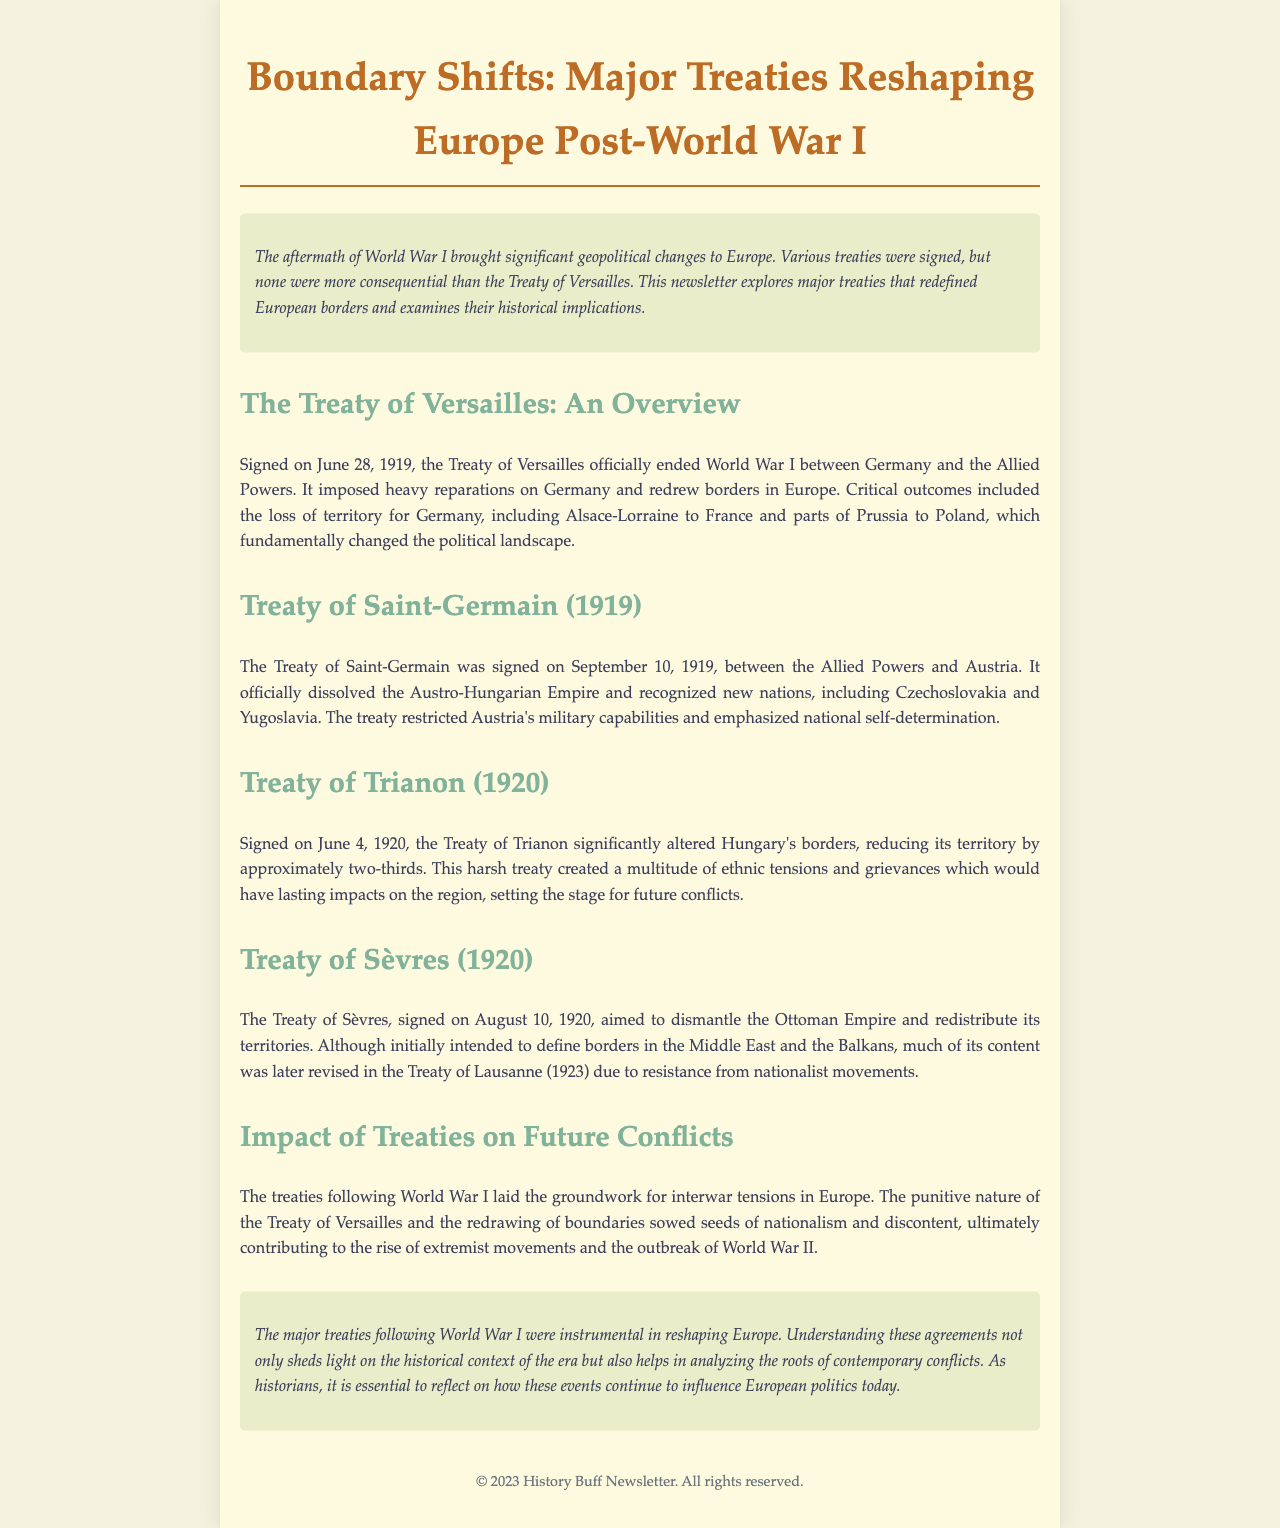What date was the Treaty of Versailles signed? The Treaty of Versailles was signed on June 28, 1919.
Answer: June 28, 1919 What was a major outcome of the Treaty of Versailles? A significant outcome of the Treaty of Versailles was the loss of territory for Germany.
Answer: Loss of territory for Germany Which territory did Germany lose to France? Germany lost Alsace-Lorraine to France as a result of the treaty.
Answer: Alsace-Lorraine What did the Treaty of Saint-Germain officially dissolve? The Treaty of Saint-Germain officially dissolved the Austro-Hungarian Empire.
Answer: Austro-Hungarian Empire How much territory did the Treaty of Trianon reduce Hungary's land by? The Treaty of Trianon reduced Hungary's territory by approximately two-thirds.
Answer: Approximately two-thirds What was the main aim of the Treaty of Sèvres? The main aim of the Treaty of Sèvres was to dismantle the Ottoman Empire.
Answer: Dismantle the Ottoman Empire What historical implications did the treaties have on the future? The treaties contributed to the rise of extremist movements leading to World War II.
Answer: Rise of extremist movements What theme is emphasized in the conclusion of the document? The conclusion emphasizes the importance of understanding the historical context of these treaties.
Answer: Historical context of treaties 